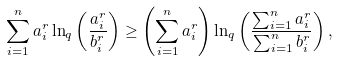Convert formula to latex. <formula><loc_0><loc_0><loc_500><loc_500>\sum _ { i = 1 } ^ { n } a _ { i } ^ { r } \ln _ { q } \left ( \frac { a _ { i } ^ { r } } { b _ { i } ^ { r } } \right ) \geq \left ( \sum _ { i = 1 } ^ { n } a _ { i } ^ { r } \right ) \ln _ { q } \left ( \frac { \sum _ { i = 1 } ^ { n } a _ { i } ^ { r } } { \sum _ { i = 1 } ^ { n } b _ { i } ^ { r } } \right ) ,</formula> 